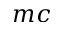Convert formula to latex. <formula><loc_0><loc_0><loc_500><loc_500>m c</formula> 